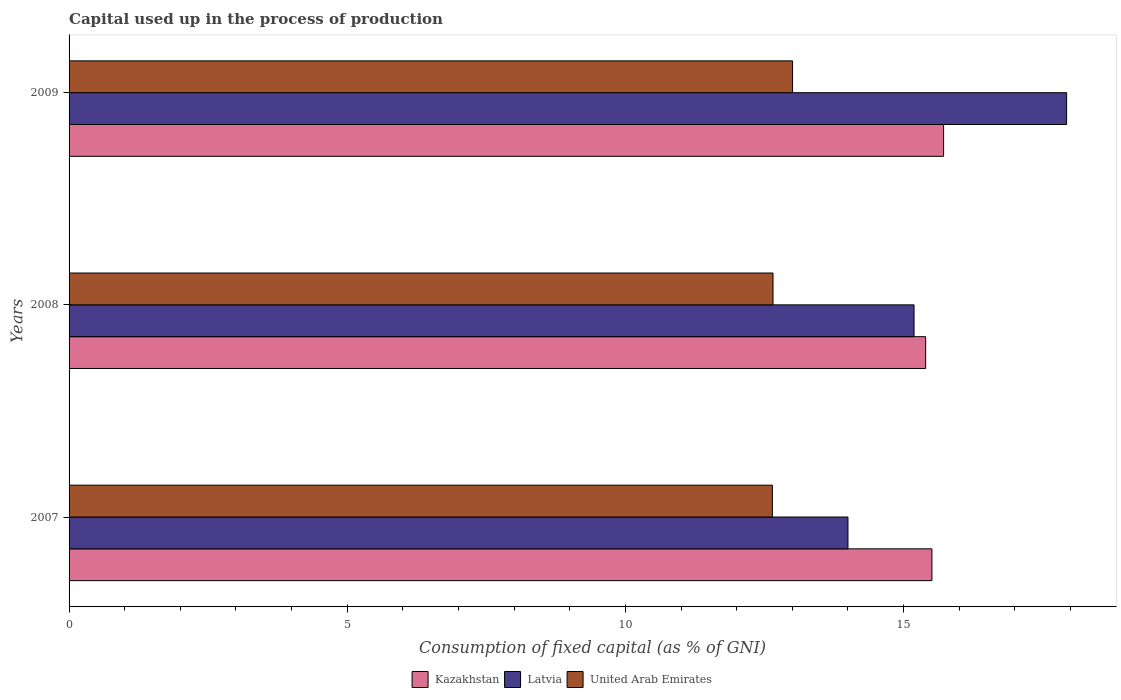Are the number of bars per tick equal to the number of legend labels?
Keep it short and to the point. Yes. Are the number of bars on each tick of the Y-axis equal?
Provide a short and direct response. Yes. How many bars are there on the 1st tick from the top?
Offer a terse response. 3. What is the capital used up in the process of production in Kazakhstan in 2008?
Keep it short and to the point. 15.4. Across all years, what is the maximum capital used up in the process of production in Kazakhstan?
Your response must be concise. 15.72. Across all years, what is the minimum capital used up in the process of production in Latvia?
Offer a very short reply. 14. In which year was the capital used up in the process of production in United Arab Emirates maximum?
Provide a succinct answer. 2009. In which year was the capital used up in the process of production in Kazakhstan minimum?
Your answer should be compact. 2008. What is the total capital used up in the process of production in United Arab Emirates in the graph?
Ensure brevity in your answer.  38.3. What is the difference between the capital used up in the process of production in Latvia in 2007 and that in 2009?
Ensure brevity in your answer.  -3.93. What is the difference between the capital used up in the process of production in United Arab Emirates in 2008 and the capital used up in the process of production in Kazakhstan in 2007?
Make the answer very short. -2.86. What is the average capital used up in the process of production in Latvia per year?
Your response must be concise. 15.71. In the year 2007, what is the difference between the capital used up in the process of production in United Arab Emirates and capital used up in the process of production in Latvia?
Offer a terse response. -1.36. In how many years, is the capital used up in the process of production in United Arab Emirates greater than 15 %?
Your answer should be compact. 0. What is the ratio of the capital used up in the process of production in United Arab Emirates in 2007 to that in 2008?
Your answer should be very brief. 1. Is the capital used up in the process of production in Kazakhstan in 2007 less than that in 2008?
Keep it short and to the point. No. What is the difference between the highest and the second highest capital used up in the process of production in Latvia?
Make the answer very short. 2.74. What is the difference between the highest and the lowest capital used up in the process of production in United Arab Emirates?
Offer a very short reply. 0.36. Is the sum of the capital used up in the process of production in United Arab Emirates in 2007 and 2009 greater than the maximum capital used up in the process of production in Latvia across all years?
Provide a succinct answer. Yes. What does the 1st bar from the top in 2008 represents?
Your answer should be very brief. United Arab Emirates. What does the 1st bar from the bottom in 2008 represents?
Your answer should be very brief. Kazakhstan. Is it the case that in every year, the sum of the capital used up in the process of production in United Arab Emirates and capital used up in the process of production in Latvia is greater than the capital used up in the process of production in Kazakhstan?
Your response must be concise. Yes. Are the values on the major ticks of X-axis written in scientific E-notation?
Offer a terse response. No. Does the graph contain grids?
Provide a short and direct response. No. How are the legend labels stacked?
Keep it short and to the point. Horizontal. What is the title of the graph?
Make the answer very short. Capital used up in the process of production. Does "Low & middle income" appear as one of the legend labels in the graph?
Your answer should be compact. No. What is the label or title of the X-axis?
Offer a very short reply. Consumption of fixed capital (as % of GNI). What is the label or title of the Y-axis?
Provide a short and direct response. Years. What is the Consumption of fixed capital (as % of GNI) in Kazakhstan in 2007?
Give a very brief answer. 15.51. What is the Consumption of fixed capital (as % of GNI) of Latvia in 2007?
Your answer should be very brief. 14. What is the Consumption of fixed capital (as % of GNI) of United Arab Emirates in 2007?
Your answer should be compact. 12.64. What is the Consumption of fixed capital (as % of GNI) in Kazakhstan in 2008?
Your response must be concise. 15.4. What is the Consumption of fixed capital (as % of GNI) of Latvia in 2008?
Provide a succinct answer. 15.19. What is the Consumption of fixed capital (as % of GNI) of United Arab Emirates in 2008?
Keep it short and to the point. 12.65. What is the Consumption of fixed capital (as % of GNI) in Kazakhstan in 2009?
Provide a short and direct response. 15.72. What is the Consumption of fixed capital (as % of GNI) of Latvia in 2009?
Keep it short and to the point. 17.93. What is the Consumption of fixed capital (as % of GNI) of United Arab Emirates in 2009?
Provide a succinct answer. 13.01. Across all years, what is the maximum Consumption of fixed capital (as % of GNI) in Kazakhstan?
Ensure brevity in your answer.  15.72. Across all years, what is the maximum Consumption of fixed capital (as % of GNI) in Latvia?
Keep it short and to the point. 17.93. Across all years, what is the maximum Consumption of fixed capital (as % of GNI) of United Arab Emirates?
Your answer should be very brief. 13.01. Across all years, what is the minimum Consumption of fixed capital (as % of GNI) in Kazakhstan?
Your response must be concise. 15.4. Across all years, what is the minimum Consumption of fixed capital (as % of GNI) of Latvia?
Provide a short and direct response. 14. Across all years, what is the minimum Consumption of fixed capital (as % of GNI) of United Arab Emirates?
Offer a terse response. 12.64. What is the total Consumption of fixed capital (as % of GNI) in Kazakhstan in the graph?
Keep it short and to the point. 46.63. What is the total Consumption of fixed capital (as % of GNI) in Latvia in the graph?
Your response must be concise. 47.12. What is the total Consumption of fixed capital (as % of GNI) of United Arab Emirates in the graph?
Your answer should be very brief. 38.3. What is the difference between the Consumption of fixed capital (as % of GNI) of Kazakhstan in 2007 and that in 2008?
Your response must be concise. 0.11. What is the difference between the Consumption of fixed capital (as % of GNI) in Latvia in 2007 and that in 2008?
Provide a short and direct response. -1.19. What is the difference between the Consumption of fixed capital (as % of GNI) in United Arab Emirates in 2007 and that in 2008?
Give a very brief answer. -0.01. What is the difference between the Consumption of fixed capital (as % of GNI) in Kazakhstan in 2007 and that in 2009?
Your answer should be very brief. -0.21. What is the difference between the Consumption of fixed capital (as % of GNI) of Latvia in 2007 and that in 2009?
Your answer should be compact. -3.93. What is the difference between the Consumption of fixed capital (as % of GNI) of United Arab Emirates in 2007 and that in 2009?
Offer a terse response. -0.36. What is the difference between the Consumption of fixed capital (as % of GNI) of Kazakhstan in 2008 and that in 2009?
Make the answer very short. -0.32. What is the difference between the Consumption of fixed capital (as % of GNI) of Latvia in 2008 and that in 2009?
Offer a terse response. -2.74. What is the difference between the Consumption of fixed capital (as % of GNI) of United Arab Emirates in 2008 and that in 2009?
Provide a succinct answer. -0.35. What is the difference between the Consumption of fixed capital (as % of GNI) in Kazakhstan in 2007 and the Consumption of fixed capital (as % of GNI) in Latvia in 2008?
Your response must be concise. 0.32. What is the difference between the Consumption of fixed capital (as % of GNI) in Kazakhstan in 2007 and the Consumption of fixed capital (as % of GNI) in United Arab Emirates in 2008?
Your response must be concise. 2.86. What is the difference between the Consumption of fixed capital (as % of GNI) in Latvia in 2007 and the Consumption of fixed capital (as % of GNI) in United Arab Emirates in 2008?
Your response must be concise. 1.35. What is the difference between the Consumption of fixed capital (as % of GNI) of Kazakhstan in 2007 and the Consumption of fixed capital (as % of GNI) of Latvia in 2009?
Offer a very short reply. -2.42. What is the difference between the Consumption of fixed capital (as % of GNI) of Kazakhstan in 2007 and the Consumption of fixed capital (as % of GNI) of United Arab Emirates in 2009?
Provide a short and direct response. 2.5. What is the difference between the Consumption of fixed capital (as % of GNI) of Latvia in 2007 and the Consumption of fixed capital (as % of GNI) of United Arab Emirates in 2009?
Ensure brevity in your answer.  1. What is the difference between the Consumption of fixed capital (as % of GNI) of Kazakhstan in 2008 and the Consumption of fixed capital (as % of GNI) of Latvia in 2009?
Your answer should be very brief. -2.53. What is the difference between the Consumption of fixed capital (as % of GNI) in Kazakhstan in 2008 and the Consumption of fixed capital (as % of GNI) in United Arab Emirates in 2009?
Make the answer very short. 2.39. What is the difference between the Consumption of fixed capital (as % of GNI) in Latvia in 2008 and the Consumption of fixed capital (as % of GNI) in United Arab Emirates in 2009?
Ensure brevity in your answer.  2.18. What is the average Consumption of fixed capital (as % of GNI) of Kazakhstan per year?
Provide a succinct answer. 15.54. What is the average Consumption of fixed capital (as % of GNI) in Latvia per year?
Provide a succinct answer. 15.71. What is the average Consumption of fixed capital (as % of GNI) of United Arab Emirates per year?
Provide a succinct answer. 12.77. In the year 2007, what is the difference between the Consumption of fixed capital (as % of GNI) of Kazakhstan and Consumption of fixed capital (as % of GNI) of Latvia?
Ensure brevity in your answer.  1.51. In the year 2007, what is the difference between the Consumption of fixed capital (as % of GNI) in Kazakhstan and Consumption of fixed capital (as % of GNI) in United Arab Emirates?
Keep it short and to the point. 2.87. In the year 2007, what is the difference between the Consumption of fixed capital (as % of GNI) of Latvia and Consumption of fixed capital (as % of GNI) of United Arab Emirates?
Give a very brief answer. 1.36. In the year 2008, what is the difference between the Consumption of fixed capital (as % of GNI) in Kazakhstan and Consumption of fixed capital (as % of GNI) in Latvia?
Your answer should be very brief. 0.21. In the year 2008, what is the difference between the Consumption of fixed capital (as % of GNI) in Kazakhstan and Consumption of fixed capital (as % of GNI) in United Arab Emirates?
Keep it short and to the point. 2.74. In the year 2008, what is the difference between the Consumption of fixed capital (as % of GNI) of Latvia and Consumption of fixed capital (as % of GNI) of United Arab Emirates?
Your answer should be compact. 2.54. In the year 2009, what is the difference between the Consumption of fixed capital (as % of GNI) in Kazakhstan and Consumption of fixed capital (as % of GNI) in Latvia?
Your answer should be compact. -2.21. In the year 2009, what is the difference between the Consumption of fixed capital (as % of GNI) in Kazakhstan and Consumption of fixed capital (as % of GNI) in United Arab Emirates?
Your answer should be compact. 2.72. In the year 2009, what is the difference between the Consumption of fixed capital (as % of GNI) in Latvia and Consumption of fixed capital (as % of GNI) in United Arab Emirates?
Your answer should be compact. 4.93. What is the ratio of the Consumption of fixed capital (as % of GNI) in Kazakhstan in 2007 to that in 2008?
Your response must be concise. 1.01. What is the ratio of the Consumption of fixed capital (as % of GNI) of Latvia in 2007 to that in 2008?
Your answer should be compact. 0.92. What is the ratio of the Consumption of fixed capital (as % of GNI) in Kazakhstan in 2007 to that in 2009?
Offer a very short reply. 0.99. What is the ratio of the Consumption of fixed capital (as % of GNI) in Latvia in 2007 to that in 2009?
Your response must be concise. 0.78. What is the ratio of the Consumption of fixed capital (as % of GNI) in United Arab Emirates in 2007 to that in 2009?
Your answer should be very brief. 0.97. What is the ratio of the Consumption of fixed capital (as % of GNI) of Kazakhstan in 2008 to that in 2009?
Your answer should be very brief. 0.98. What is the ratio of the Consumption of fixed capital (as % of GNI) of Latvia in 2008 to that in 2009?
Ensure brevity in your answer.  0.85. What is the difference between the highest and the second highest Consumption of fixed capital (as % of GNI) of Kazakhstan?
Provide a succinct answer. 0.21. What is the difference between the highest and the second highest Consumption of fixed capital (as % of GNI) of Latvia?
Offer a terse response. 2.74. What is the difference between the highest and the second highest Consumption of fixed capital (as % of GNI) of United Arab Emirates?
Provide a succinct answer. 0.35. What is the difference between the highest and the lowest Consumption of fixed capital (as % of GNI) in Kazakhstan?
Provide a short and direct response. 0.32. What is the difference between the highest and the lowest Consumption of fixed capital (as % of GNI) in Latvia?
Your answer should be very brief. 3.93. What is the difference between the highest and the lowest Consumption of fixed capital (as % of GNI) in United Arab Emirates?
Offer a very short reply. 0.36. 